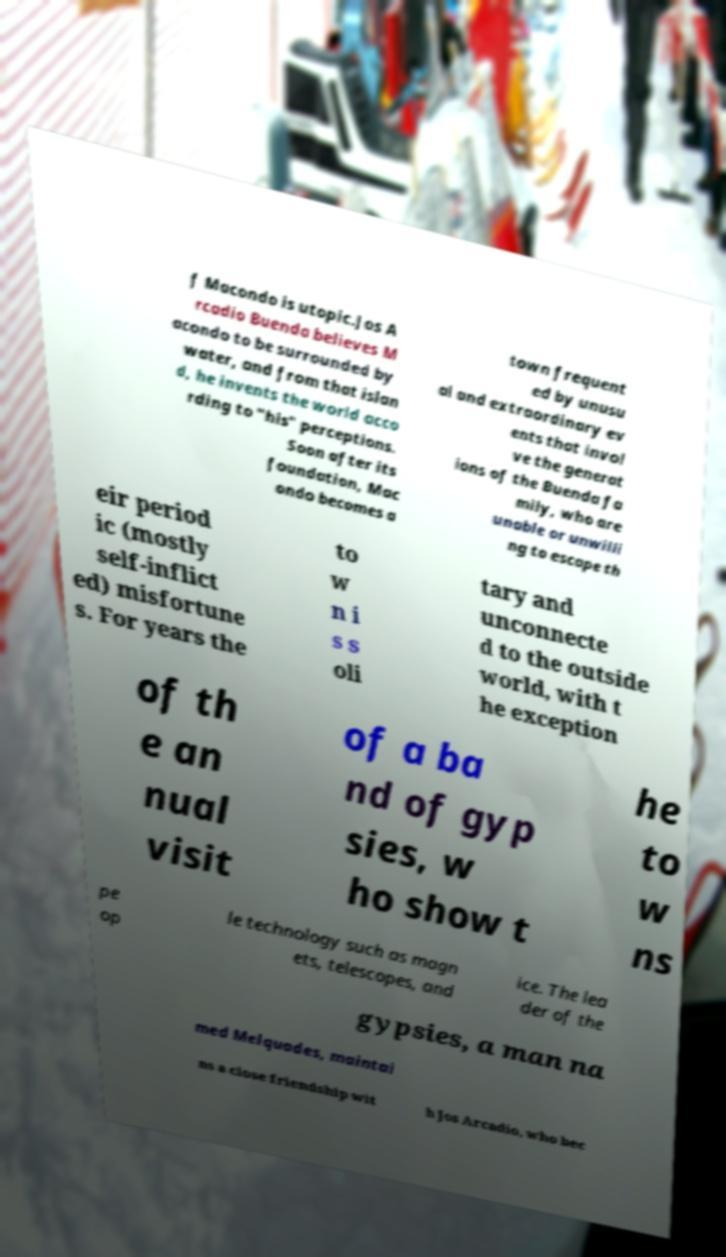For documentation purposes, I need the text within this image transcribed. Could you provide that? f Macondo is utopic.Jos A rcadio Buenda believes M acondo to be surrounded by water, and from that islan d, he invents the world acco rding to "his" perceptions. Soon after its foundation, Mac ondo becomes a town frequent ed by unusu al and extraordinary ev ents that invol ve the generat ions of the Buenda fa mily, who are unable or unwilli ng to escape th eir period ic (mostly self-inflict ed) misfortune s. For years the to w n i s s oli tary and unconnecte d to the outside world, with t he exception of th e an nual visit of a ba nd of gyp sies, w ho show t he to w ns pe op le technology such as magn ets, telescopes, and ice. The lea der of the gypsies, a man na med Melquades, maintai ns a close friendship wit h Jos Arcadio, who bec 